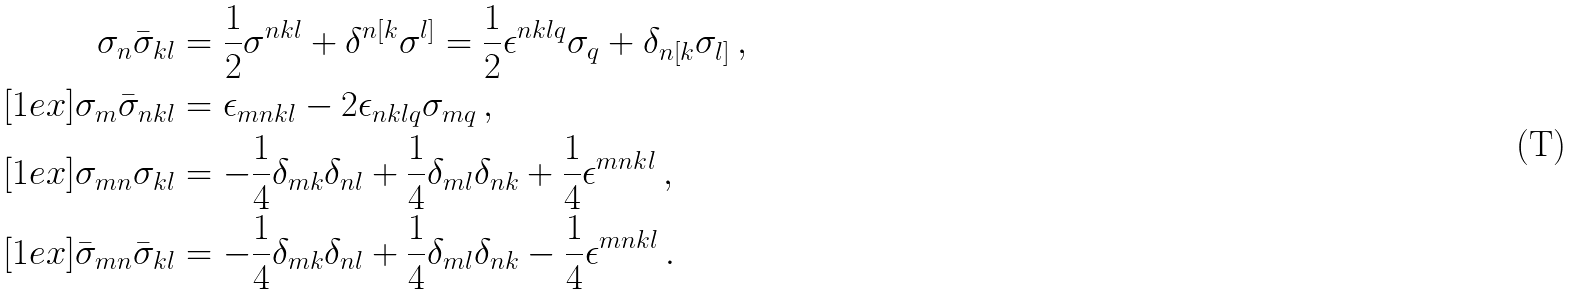Convert formula to latex. <formula><loc_0><loc_0><loc_500><loc_500>\sigma _ { n } \bar { \sigma } _ { k l } & = \frac { 1 } { 2 } \sigma ^ { n k l } + \delta ^ { n [ k } \sigma ^ { l ] } = \frac { 1 } { 2 } \epsilon ^ { n k l q } \sigma _ { q } + \delta _ { n [ k } \sigma _ { l ] } \, , \\ [ 1 e x ] \sigma _ { m } \bar { \sigma } _ { n k l } & = \epsilon _ { m n k l } - 2 \epsilon _ { n k l q } \sigma _ { m q } \, , \\ [ 1 e x ] \sigma _ { m n } \sigma _ { k l } & = - \frac { 1 } { 4 } \delta _ { m k } \delta _ { n l } + \frac { 1 } { 4 } \delta _ { m l } \delta _ { n k } + \frac { 1 } { 4 } \epsilon ^ { m n k l } \, , \\ [ 1 e x ] \bar { \sigma } _ { m n } \bar { \sigma } _ { k l } & = - \frac { 1 } { 4 } \delta _ { m k } \delta _ { n l } + \frac { 1 } { 4 } \delta _ { m l } \delta _ { n k } - \frac { 1 } { 4 } \epsilon ^ { m n k l } \, .</formula> 